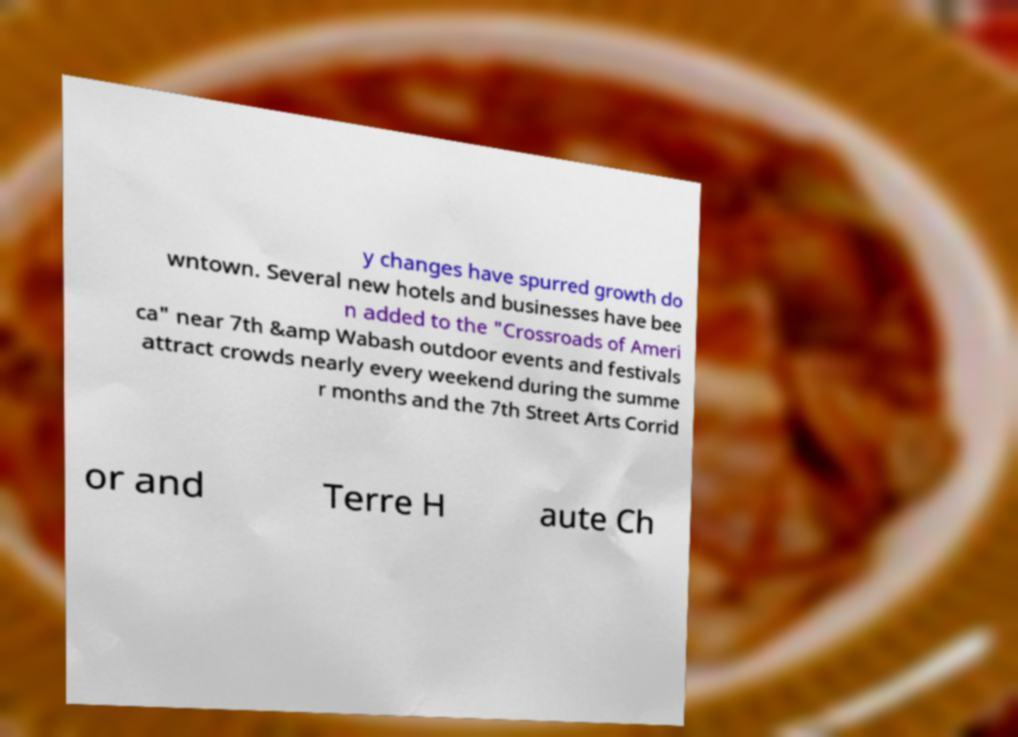Could you extract and type out the text from this image? y changes have spurred growth do wntown. Several new hotels and businesses have bee n added to the "Crossroads of Ameri ca" near 7th &amp Wabash outdoor events and festivals attract crowds nearly every weekend during the summe r months and the 7th Street Arts Corrid or and Terre H aute Ch 